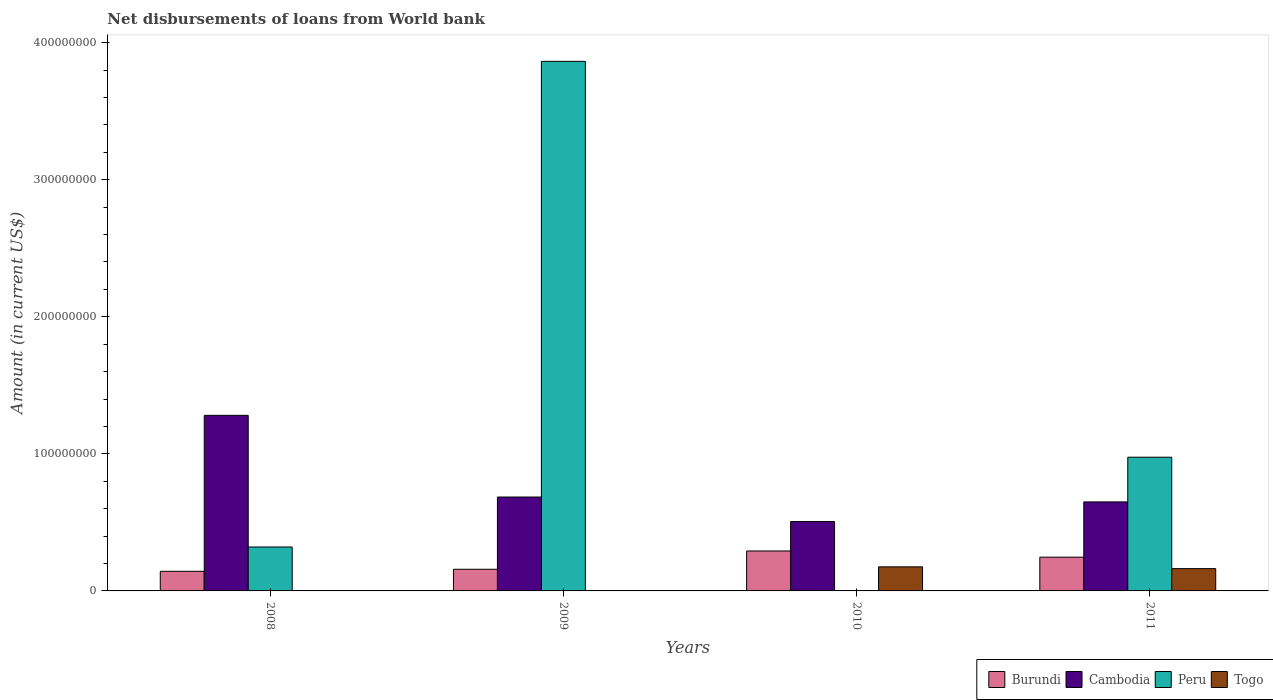How many groups of bars are there?
Give a very brief answer. 4. Are the number of bars per tick equal to the number of legend labels?
Your response must be concise. No. How many bars are there on the 1st tick from the left?
Provide a short and direct response. 3. What is the label of the 3rd group of bars from the left?
Your answer should be very brief. 2010. In how many cases, is the number of bars for a given year not equal to the number of legend labels?
Ensure brevity in your answer.  3. What is the amount of loan disbursed from World Bank in Togo in 2010?
Provide a succinct answer. 1.76e+07. Across all years, what is the maximum amount of loan disbursed from World Bank in Togo?
Give a very brief answer. 1.76e+07. Across all years, what is the minimum amount of loan disbursed from World Bank in Burundi?
Provide a short and direct response. 1.43e+07. In which year was the amount of loan disbursed from World Bank in Togo maximum?
Provide a succinct answer. 2010. What is the total amount of loan disbursed from World Bank in Cambodia in the graph?
Keep it short and to the point. 3.12e+08. What is the difference between the amount of loan disbursed from World Bank in Burundi in 2008 and that in 2009?
Provide a succinct answer. -1.48e+06. What is the difference between the amount of loan disbursed from World Bank in Burundi in 2011 and the amount of loan disbursed from World Bank in Peru in 2009?
Give a very brief answer. -3.62e+08. What is the average amount of loan disbursed from World Bank in Cambodia per year?
Ensure brevity in your answer.  7.80e+07. In the year 2011, what is the difference between the amount of loan disbursed from World Bank in Peru and amount of loan disbursed from World Bank in Cambodia?
Keep it short and to the point. 3.26e+07. What is the ratio of the amount of loan disbursed from World Bank in Togo in 2010 to that in 2011?
Provide a short and direct response. 1.08. Is the amount of loan disbursed from World Bank in Burundi in 2008 less than that in 2011?
Provide a short and direct response. Yes. Is the difference between the amount of loan disbursed from World Bank in Peru in 2009 and 2011 greater than the difference between the amount of loan disbursed from World Bank in Cambodia in 2009 and 2011?
Offer a terse response. Yes. What is the difference between the highest and the second highest amount of loan disbursed from World Bank in Cambodia?
Provide a short and direct response. 5.96e+07. What is the difference between the highest and the lowest amount of loan disbursed from World Bank in Togo?
Your answer should be very brief. 1.76e+07. Is it the case that in every year, the sum of the amount of loan disbursed from World Bank in Cambodia and amount of loan disbursed from World Bank in Burundi is greater than the sum of amount of loan disbursed from World Bank in Peru and amount of loan disbursed from World Bank in Togo?
Your answer should be compact. No. How many bars are there?
Provide a short and direct response. 13. Are all the bars in the graph horizontal?
Make the answer very short. No. How many years are there in the graph?
Your response must be concise. 4. What is the difference between two consecutive major ticks on the Y-axis?
Give a very brief answer. 1.00e+08. Are the values on the major ticks of Y-axis written in scientific E-notation?
Make the answer very short. No. Does the graph contain grids?
Keep it short and to the point. No. Where does the legend appear in the graph?
Offer a very short reply. Bottom right. How many legend labels are there?
Offer a very short reply. 4. What is the title of the graph?
Offer a very short reply. Net disbursements of loans from World bank. What is the label or title of the X-axis?
Your response must be concise. Years. What is the Amount (in current US$) in Burundi in 2008?
Ensure brevity in your answer.  1.43e+07. What is the Amount (in current US$) of Cambodia in 2008?
Provide a short and direct response. 1.28e+08. What is the Amount (in current US$) of Peru in 2008?
Your response must be concise. 3.20e+07. What is the Amount (in current US$) in Burundi in 2009?
Provide a succinct answer. 1.58e+07. What is the Amount (in current US$) in Cambodia in 2009?
Offer a terse response. 6.85e+07. What is the Amount (in current US$) of Peru in 2009?
Provide a succinct answer. 3.86e+08. What is the Amount (in current US$) of Togo in 2009?
Give a very brief answer. 0. What is the Amount (in current US$) in Burundi in 2010?
Provide a succinct answer. 2.91e+07. What is the Amount (in current US$) in Cambodia in 2010?
Ensure brevity in your answer.  5.06e+07. What is the Amount (in current US$) in Togo in 2010?
Give a very brief answer. 1.76e+07. What is the Amount (in current US$) of Burundi in 2011?
Your answer should be very brief. 2.46e+07. What is the Amount (in current US$) of Cambodia in 2011?
Your answer should be compact. 6.49e+07. What is the Amount (in current US$) of Peru in 2011?
Give a very brief answer. 9.75e+07. What is the Amount (in current US$) in Togo in 2011?
Offer a terse response. 1.63e+07. Across all years, what is the maximum Amount (in current US$) in Burundi?
Offer a terse response. 2.91e+07. Across all years, what is the maximum Amount (in current US$) in Cambodia?
Offer a terse response. 1.28e+08. Across all years, what is the maximum Amount (in current US$) of Peru?
Make the answer very short. 3.86e+08. Across all years, what is the maximum Amount (in current US$) in Togo?
Your answer should be compact. 1.76e+07. Across all years, what is the minimum Amount (in current US$) in Burundi?
Your answer should be compact. 1.43e+07. Across all years, what is the minimum Amount (in current US$) of Cambodia?
Give a very brief answer. 5.06e+07. Across all years, what is the minimum Amount (in current US$) of Togo?
Provide a succinct answer. 0. What is the total Amount (in current US$) of Burundi in the graph?
Your response must be concise. 8.39e+07. What is the total Amount (in current US$) in Cambodia in the graph?
Make the answer very short. 3.12e+08. What is the total Amount (in current US$) in Peru in the graph?
Offer a very short reply. 5.16e+08. What is the total Amount (in current US$) of Togo in the graph?
Provide a short and direct response. 3.38e+07. What is the difference between the Amount (in current US$) of Burundi in 2008 and that in 2009?
Provide a short and direct response. -1.48e+06. What is the difference between the Amount (in current US$) of Cambodia in 2008 and that in 2009?
Your answer should be compact. 5.96e+07. What is the difference between the Amount (in current US$) in Peru in 2008 and that in 2009?
Provide a succinct answer. -3.54e+08. What is the difference between the Amount (in current US$) of Burundi in 2008 and that in 2010?
Ensure brevity in your answer.  -1.48e+07. What is the difference between the Amount (in current US$) in Cambodia in 2008 and that in 2010?
Give a very brief answer. 7.75e+07. What is the difference between the Amount (in current US$) of Burundi in 2008 and that in 2011?
Your answer should be compact. -1.03e+07. What is the difference between the Amount (in current US$) of Cambodia in 2008 and that in 2011?
Make the answer very short. 6.32e+07. What is the difference between the Amount (in current US$) of Peru in 2008 and that in 2011?
Your response must be concise. -6.55e+07. What is the difference between the Amount (in current US$) in Burundi in 2009 and that in 2010?
Keep it short and to the point. -1.34e+07. What is the difference between the Amount (in current US$) of Cambodia in 2009 and that in 2010?
Make the answer very short. 1.79e+07. What is the difference between the Amount (in current US$) in Burundi in 2009 and that in 2011?
Keep it short and to the point. -8.84e+06. What is the difference between the Amount (in current US$) in Cambodia in 2009 and that in 2011?
Offer a terse response. 3.57e+06. What is the difference between the Amount (in current US$) in Peru in 2009 and that in 2011?
Make the answer very short. 2.89e+08. What is the difference between the Amount (in current US$) of Burundi in 2010 and that in 2011?
Offer a terse response. 4.52e+06. What is the difference between the Amount (in current US$) of Cambodia in 2010 and that in 2011?
Offer a terse response. -1.43e+07. What is the difference between the Amount (in current US$) of Togo in 2010 and that in 2011?
Ensure brevity in your answer.  1.30e+06. What is the difference between the Amount (in current US$) in Burundi in 2008 and the Amount (in current US$) in Cambodia in 2009?
Ensure brevity in your answer.  -5.42e+07. What is the difference between the Amount (in current US$) in Burundi in 2008 and the Amount (in current US$) in Peru in 2009?
Offer a very short reply. -3.72e+08. What is the difference between the Amount (in current US$) in Cambodia in 2008 and the Amount (in current US$) in Peru in 2009?
Make the answer very short. -2.58e+08. What is the difference between the Amount (in current US$) of Burundi in 2008 and the Amount (in current US$) of Cambodia in 2010?
Make the answer very short. -3.63e+07. What is the difference between the Amount (in current US$) in Burundi in 2008 and the Amount (in current US$) in Togo in 2010?
Give a very brief answer. -3.26e+06. What is the difference between the Amount (in current US$) of Cambodia in 2008 and the Amount (in current US$) of Togo in 2010?
Make the answer very short. 1.11e+08. What is the difference between the Amount (in current US$) of Peru in 2008 and the Amount (in current US$) of Togo in 2010?
Provide a succinct answer. 1.45e+07. What is the difference between the Amount (in current US$) in Burundi in 2008 and the Amount (in current US$) in Cambodia in 2011?
Provide a succinct answer. -5.06e+07. What is the difference between the Amount (in current US$) of Burundi in 2008 and the Amount (in current US$) of Peru in 2011?
Provide a short and direct response. -8.32e+07. What is the difference between the Amount (in current US$) in Burundi in 2008 and the Amount (in current US$) in Togo in 2011?
Ensure brevity in your answer.  -1.96e+06. What is the difference between the Amount (in current US$) in Cambodia in 2008 and the Amount (in current US$) in Peru in 2011?
Offer a terse response. 3.05e+07. What is the difference between the Amount (in current US$) in Cambodia in 2008 and the Amount (in current US$) in Togo in 2011?
Your answer should be compact. 1.12e+08. What is the difference between the Amount (in current US$) of Peru in 2008 and the Amount (in current US$) of Togo in 2011?
Provide a succinct answer. 1.58e+07. What is the difference between the Amount (in current US$) in Burundi in 2009 and the Amount (in current US$) in Cambodia in 2010?
Make the answer very short. -3.48e+07. What is the difference between the Amount (in current US$) in Burundi in 2009 and the Amount (in current US$) in Togo in 2010?
Ensure brevity in your answer.  -1.77e+06. What is the difference between the Amount (in current US$) in Cambodia in 2009 and the Amount (in current US$) in Togo in 2010?
Your response must be concise. 5.09e+07. What is the difference between the Amount (in current US$) of Peru in 2009 and the Amount (in current US$) of Togo in 2010?
Offer a terse response. 3.69e+08. What is the difference between the Amount (in current US$) of Burundi in 2009 and the Amount (in current US$) of Cambodia in 2011?
Ensure brevity in your answer.  -4.91e+07. What is the difference between the Amount (in current US$) in Burundi in 2009 and the Amount (in current US$) in Peru in 2011?
Keep it short and to the point. -8.18e+07. What is the difference between the Amount (in current US$) in Burundi in 2009 and the Amount (in current US$) in Togo in 2011?
Provide a succinct answer. -4.74e+05. What is the difference between the Amount (in current US$) in Cambodia in 2009 and the Amount (in current US$) in Peru in 2011?
Your response must be concise. -2.90e+07. What is the difference between the Amount (in current US$) of Cambodia in 2009 and the Amount (in current US$) of Togo in 2011?
Keep it short and to the point. 5.22e+07. What is the difference between the Amount (in current US$) in Peru in 2009 and the Amount (in current US$) in Togo in 2011?
Keep it short and to the point. 3.70e+08. What is the difference between the Amount (in current US$) of Burundi in 2010 and the Amount (in current US$) of Cambodia in 2011?
Provide a short and direct response. -3.58e+07. What is the difference between the Amount (in current US$) in Burundi in 2010 and the Amount (in current US$) in Peru in 2011?
Provide a succinct answer. -6.84e+07. What is the difference between the Amount (in current US$) of Burundi in 2010 and the Amount (in current US$) of Togo in 2011?
Ensure brevity in your answer.  1.29e+07. What is the difference between the Amount (in current US$) of Cambodia in 2010 and the Amount (in current US$) of Peru in 2011?
Your response must be concise. -4.69e+07. What is the difference between the Amount (in current US$) in Cambodia in 2010 and the Amount (in current US$) in Togo in 2011?
Offer a very short reply. 3.44e+07. What is the average Amount (in current US$) in Burundi per year?
Provide a succinct answer. 2.10e+07. What is the average Amount (in current US$) of Cambodia per year?
Offer a very short reply. 7.80e+07. What is the average Amount (in current US$) of Peru per year?
Give a very brief answer. 1.29e+08. What is the average Amount (in current US$) of Togo per year?
Offer a very short reply. 8.46e+06. In the year 2008, what is the difference between the Amount (in current US$) of Burundi and Amount (in current US$) of Cambodia?
Ensure brevity in your answer.  -1.14e+08. In the year 2008, what is the difference between the Amount (in current US$) in Burundi and Amount (in current US$) in Peru?
Provide a succinct answer. -1.77e+07. In the year 2008, what is the difference between the Amount (in current US$) in Cambodia and Amount (in current US$) in Peru?
Keep it short and to the point. 9.60e+07. In the year 2009, what is the difference between the Amount (in current US$) in Burundi and Amount (in current US$) in Cambodia?
Your answer should be very brief. -5.27e+07. In the year 2009, what is the difference between the Amount (in current US$) in Burundi and Amount (in current US$) in Peru?
Keep it short and to the point. -3.71e+08. In the year 2009, what is the difference between the Amount (in current US$) of Cambodia and Amount (in current US$) of Peru?
Provide a succinct answer. -3.18e+08. In the year 2010, what is the difference between the Amount (in current US$) of Burundi and Amount (in current US$) of Cambodia?
Give a very brief answer. -2.15e+07. In the year 2010, what is the difference between the Amount (in current US$) in Burundi and Amount (in current US$) in Togo?
Provide a short and direct response. 1.16e+07. In the year 2010, what is the difference between the Amount (in current US$) in Cambodia and Amount (in current US$) in Togo?
Keep it short and to the point. 3.31e+07. In the year 2011, what is the difference between the Amount (in current US$) of Burundi and Amount (in current US$) of Cambodia?
Ensure brevity in your answer.  -4.03e+07. In the year 2011, what is the difference between the Amount (in current US$) in Burundi and Amount (in current US$) in Peru?
Keep it short and to the point. -7.29e+07. In the year 2011, what is the difference between the Amount (in current US$) of Burundi and Amount (in current US$) of Togo?
Give a very brief answer. 8.37e+06. In the year 2011, what is the difference between the Amount (in current US$) in Cambodia and Amount (in current US$) in Peru?
Make the answer very short. -3.26e+07. In the year 2011, what is the difference between the Amount (in current US$) in Cambodia and Amount (in current US$) in Togo?
Provide a short and direct response. 4.87e+07. In the year 2011, what is the difference between the Amount (in current US$) of Peru and Amount (in current US$) of Togo?
Give a very brief answer. 8.13e+07. What is the ratio of the Amount (in current US$) in Burundi in 2008 to that in 2009?
Offer a very short reply. 0.91. What is the ratio of the Amount (in current US$) of Cambodia in 2008 to that in 2009?
Offer a terse response. 1.87. What is the ratio of the Amount (in current US$) of Peru in 2008 to that in 2009?
Provide a short and direct response. 0.08. What is the ratio of the Amount (in current US$) of Burundi in 2008 to that in 2010?
Give a very brief answer. 0.49. What is the ratio of the Amount (in current US$) in Cambodia in 2008 to that in 2010?
Your answer should be compact. 2.53. What is the ratio of the Amount (in current US$) of Burundi in 2008 to that in 2011?
Offer a terse response. 0.58. What is the ratio of the Amount (in current US$) of Cambodia in 2008 to that in 2011?
Offer a terse response. 1.97. What is the ratio of the Amount (in current US$) in Peru in 2008 to that in 2011?
Give a very brief answer. 0.33. What is the ratio of the Amount (in current US$) in Burundi in 2009 to that in 2010?
Offer a very short reply. 0.54. What is the ratio of the Amount (in current US$) of Cambodia in 2009 to that in 2010?
Provide a succinct answer. 1.35. What is the ratio of the Amount (in current US$) of Burundi in 2009 to that in 2011?
Provide a short and direct response. 0.64. What is the ratio of the Amount (in current US$) of Cambodia in 2009 to that in 2011?
Your response must be concise. 1.05. What is the ratio of the Amount (in current US$) in Peru in 2009 to that in 2011?
Provide a short and direct response. 3.96. What is the ratio of the Amount (in current US$) in Burundi in 2010 to that in 2011?
Give a very brief answer. 1.18. What is the ratio of the Amount (in current US$) of Cambodia in 2010 to that in 2011?
Make the answer very short. 0.78. What is the ratio of the Amount (in current US$) in Togo in 2010 to that in 2011?
Offer a terse response. 1.08. What is the difference between the highest and the second highest Amount (in current US$) in Burundi?
Offer a terse response. 4.52e+06. What is the difference between the highest and the second highest Amount (in current US$) of Cambodia?
Keep it short and to the point. 5.96e+07. What is the difference between the highest and the second highest Amount (in current US$) in Peru?
Keep it short and to the point. 2.89e+08. What is the difference between the highest and the lowest Amount (in current US$) in Burundi?
Your answer should be very brief. 1.48e+07. What is the difference between the highest and the lowest Amount (in current US$) in Cambodia?
Give a very brief answer. 7.75e+07. What is the difference between the highest and the lowest Amount (in current US$) of Peru?
Keep it short and to the point. 3.86e+08. What is the difference between the highest and the lowest Amount (in current US$) of Togo?
Give a very brief answer. 1.76e+07. 